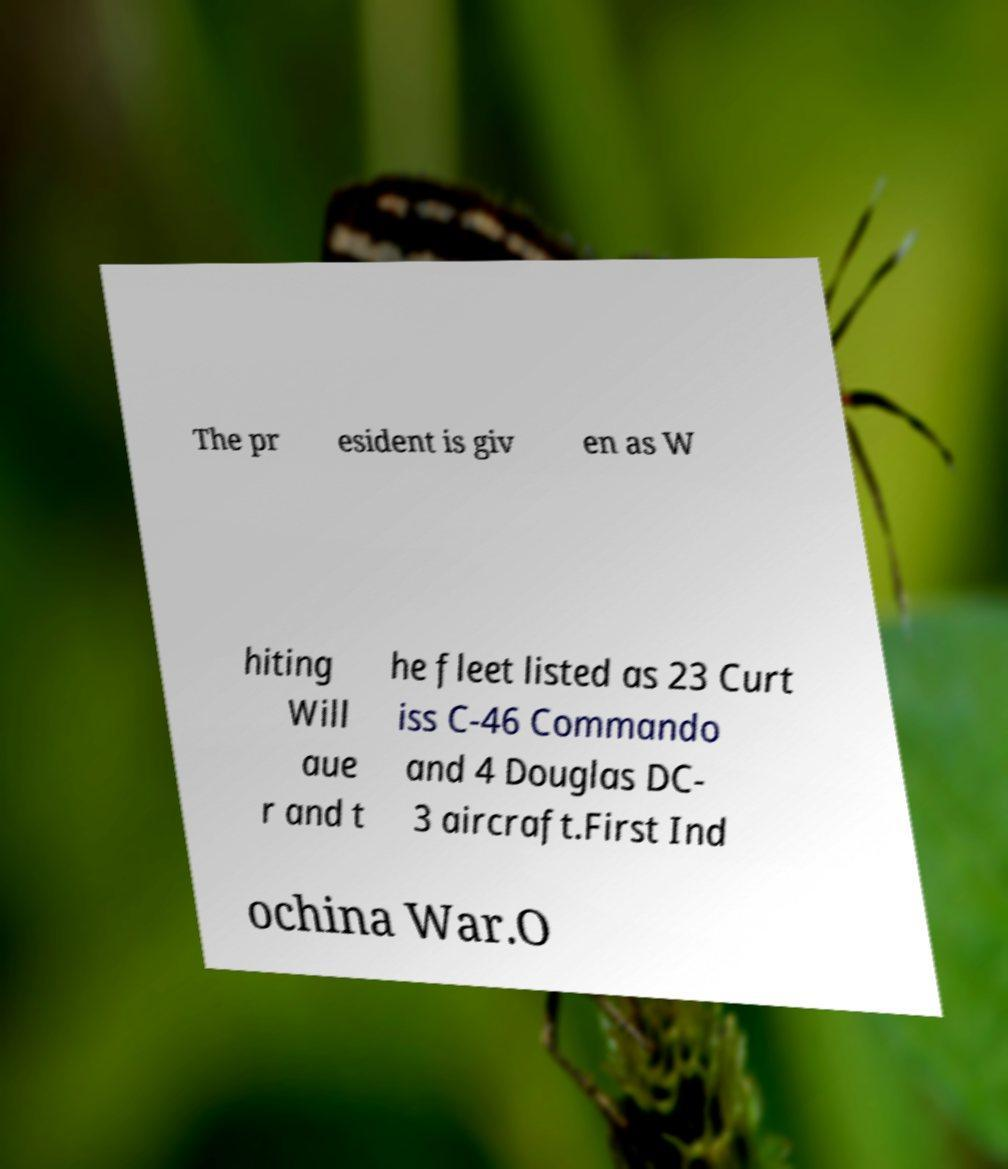Could you assist in decoding the text presented in this image and type it out clearly? The pr esident is giv en as W hiting Will aue r and t he fleet listed as 23 Curt iss C-46 Commando and 4 Douglas DC- 3 aircraft.First Ind ochina War.O 